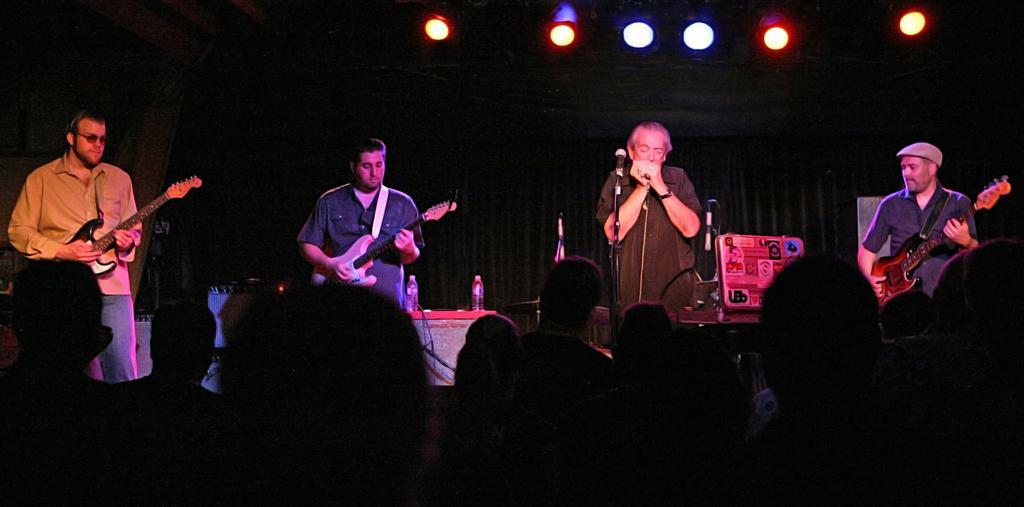Could you give a brief overview of what you see in this image? There are four people standing on the stage. On the left there are two people who are playing guitar. In the center of the image there is a man standing before him there is a mic. On the left there is a man who is playing a guitar. At the bottom of the image there is a crowd we can see lights at the top. 